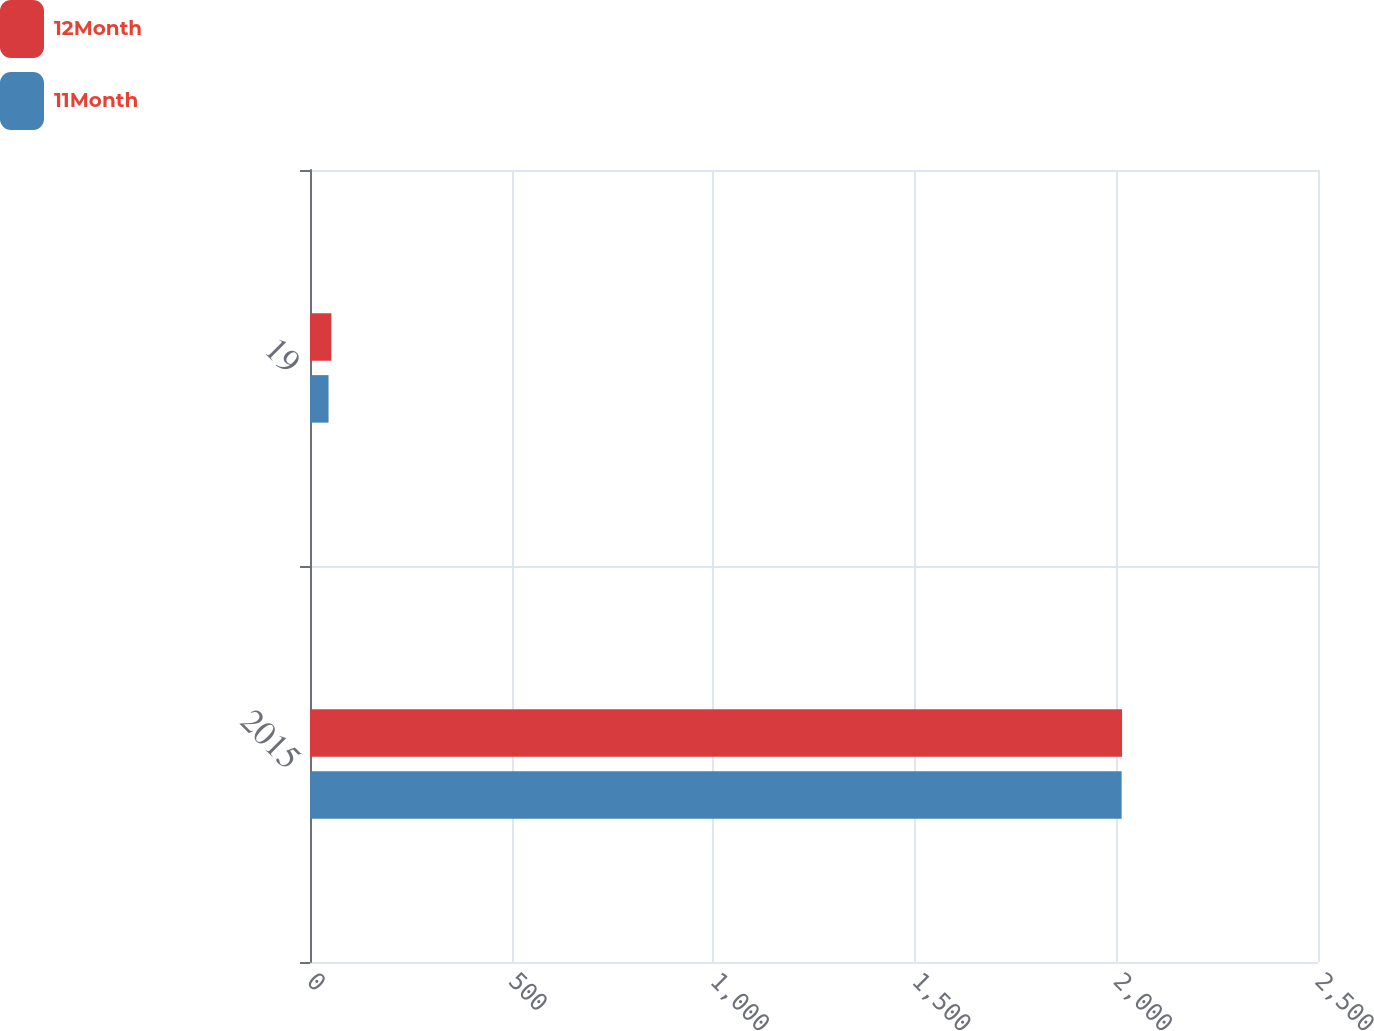Convert chart. <chart><loc_0><loc_0><loc_500><loc_500><stacked_bar_chart><ecel><fcel>2015<fcel>19<nl><fcel>12Month<fcel>2014<fcel>53<nl><fcel>11Month<fcel>2013<fcel>46<nl></chart> 